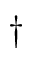Convert formula to latex. <formula><loc_0><loc_0><loc_500><loc_500>\dagger</formula> 